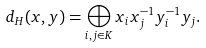Convert formula to latex. <formula><loc_0><loc_0><loc_500><loc_500>d _ { H } ( x , y ) = \bigoplus _ { i , j \in K } x _ { i } x _ { j } ^ { - 1 } y _ { i } ^ { - 1 } y _ { j } .</formula> 